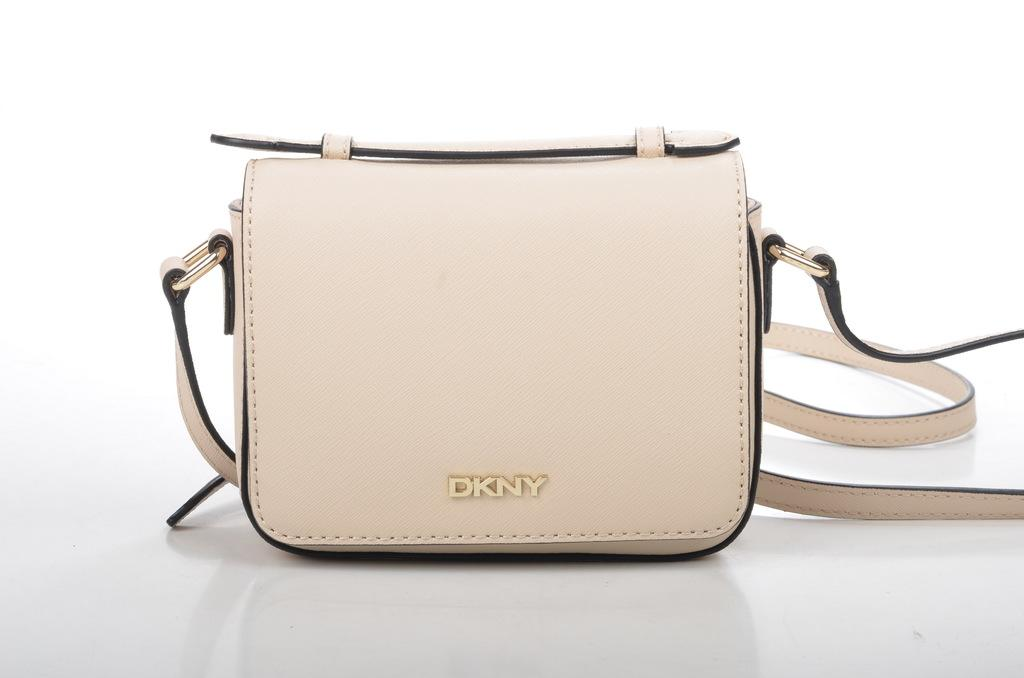What type of accessory is present in the image? There is a white handbag in the image. What can be seen on the handbag? The letters D, K, AND, and Y are visible on the handbag. What type of food is being served on the tray in the image? There is no tray or food present in the image; it only features a white handbag with letters on it. 